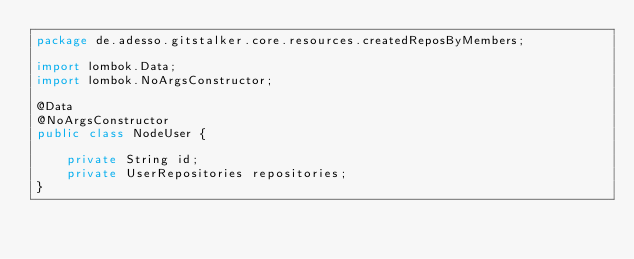Convert code to text. <code><loc_0><loc_0><loc_500><loc_500><_Java_>package de.adesso.gitstalker.core.resources.createdReposByMembers;

import lombok.Data;
import lombok.NoArgsConstructor;

@Data
@NoArgsConstructor
public class NodeUser {

    private String id;
    private UserRepositories repositories;
}
</code> 